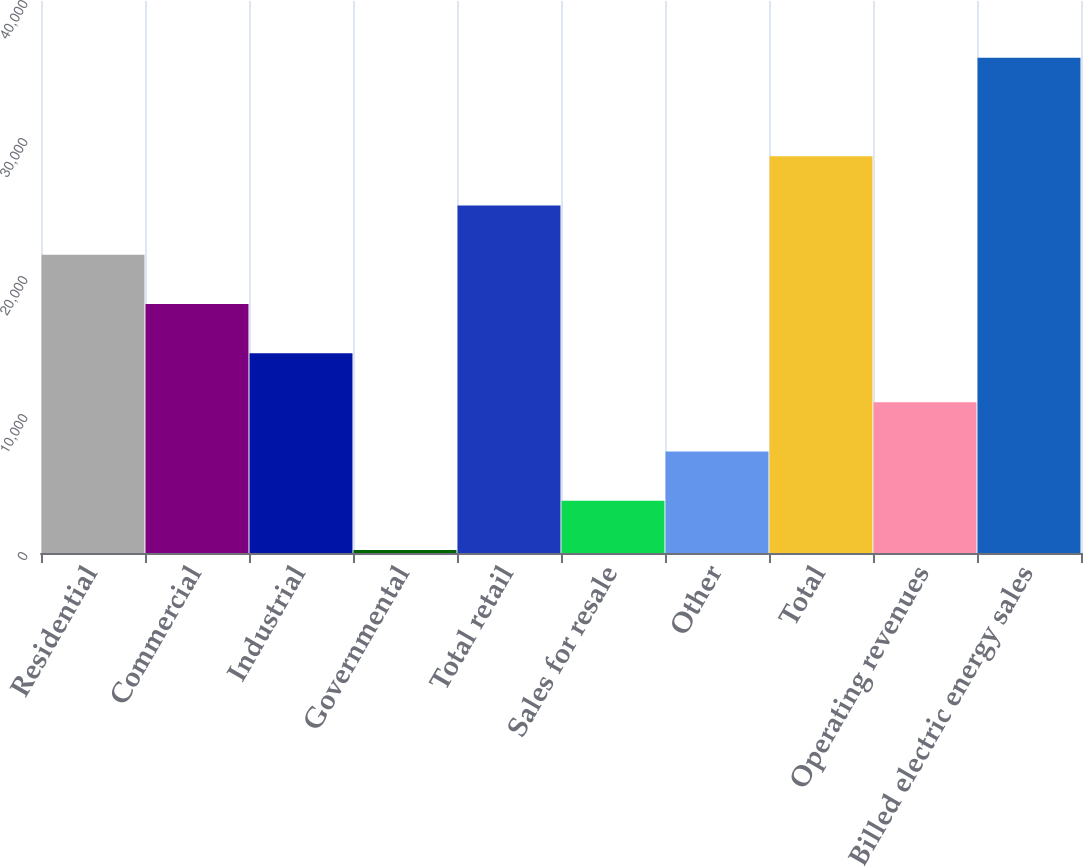<chart> <loc_0><loc_0><loc_500><loc_500><bar_chart><fcel>Residential<fcel>Commercial<fcel>Industrial<fcel>Governmental<fcel>Total retail<fcel>Sales for resale<fcel>Other<fcel>Total<fcel>Operating revenues<fcel>Billed electric energy sales<nl><fcel>21615.4<fcel>18049<fcel>14482.6<fcel>217<fcel>25181.8<fcel>3783.4<fcel>7349.8<fcel>28748.2<fcel>10916.2<fcel>35881<nl></chart> 